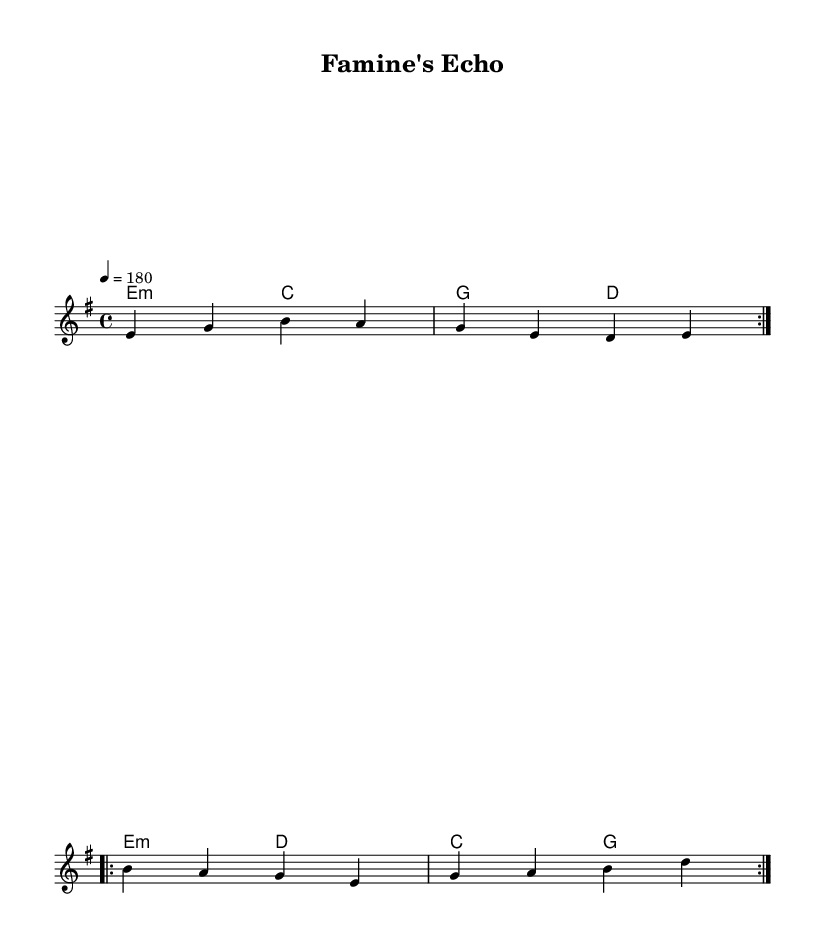What is the key signature of this music? The key signature is E minor, which has one sharp (F#). This can be determined by looking at the key indicated at the beginning of the sheet music.
Answer: E minor What is the time signature of the piece? The time signature is 4/4, indicated at the beginning of the score. This means there are four beats in each measure and the quarter note gets one beat.
Answer: 4/4 What is the tempo marking for this music? The tempo marking is 180 beats per minute, as specified by the tempo indication, and it shows how fast the piece should be played.
Answer: 180 How many times is the verse repeated? The verse is repeated two times, indicated by the "repeat volta 2" marking in the melody section for the verse.
Answer: 2 What is the primary theme conveyed in the lyrics of the chorus? The primary theme in the chorus is about resilience and not forgetting the struggles faced, as expressed through the lyrics "We won't forget, we'll stand and fight." This reflects the spirit of perseverance characteristic of punk music.
Answer: Resilience What is the main chord used in the first two measures? The main chord used in the first two measures is E minor, which is indicated in the chord changes at the beginning of the harmony section.
Answer: E minor What genre does this sheet music represent? This sheet music represents punk music, characterized by its fast-paced rhythm, straightforward structure, and themes of social issues, as reflected in both the music and lyrics.
Answer: Punk 